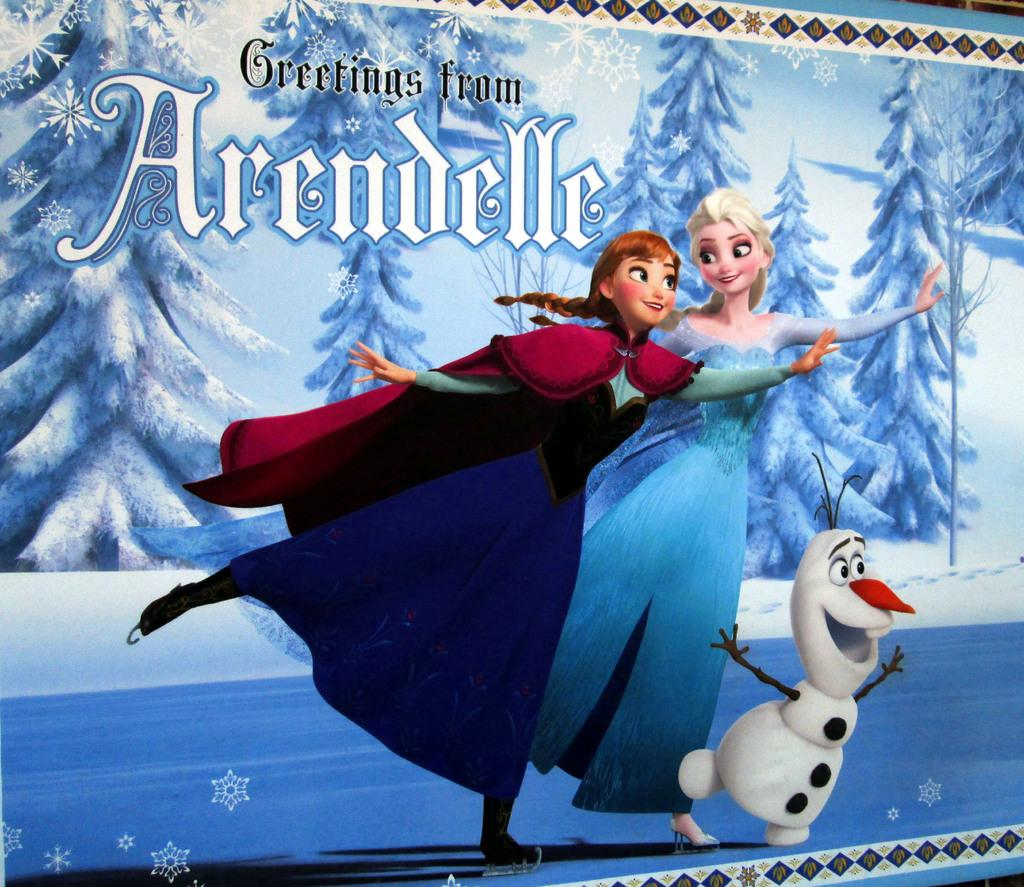Provide a one-sentence caption for the provided image. A post card featuring Frozen characters that says Greetings from Arendelle. 